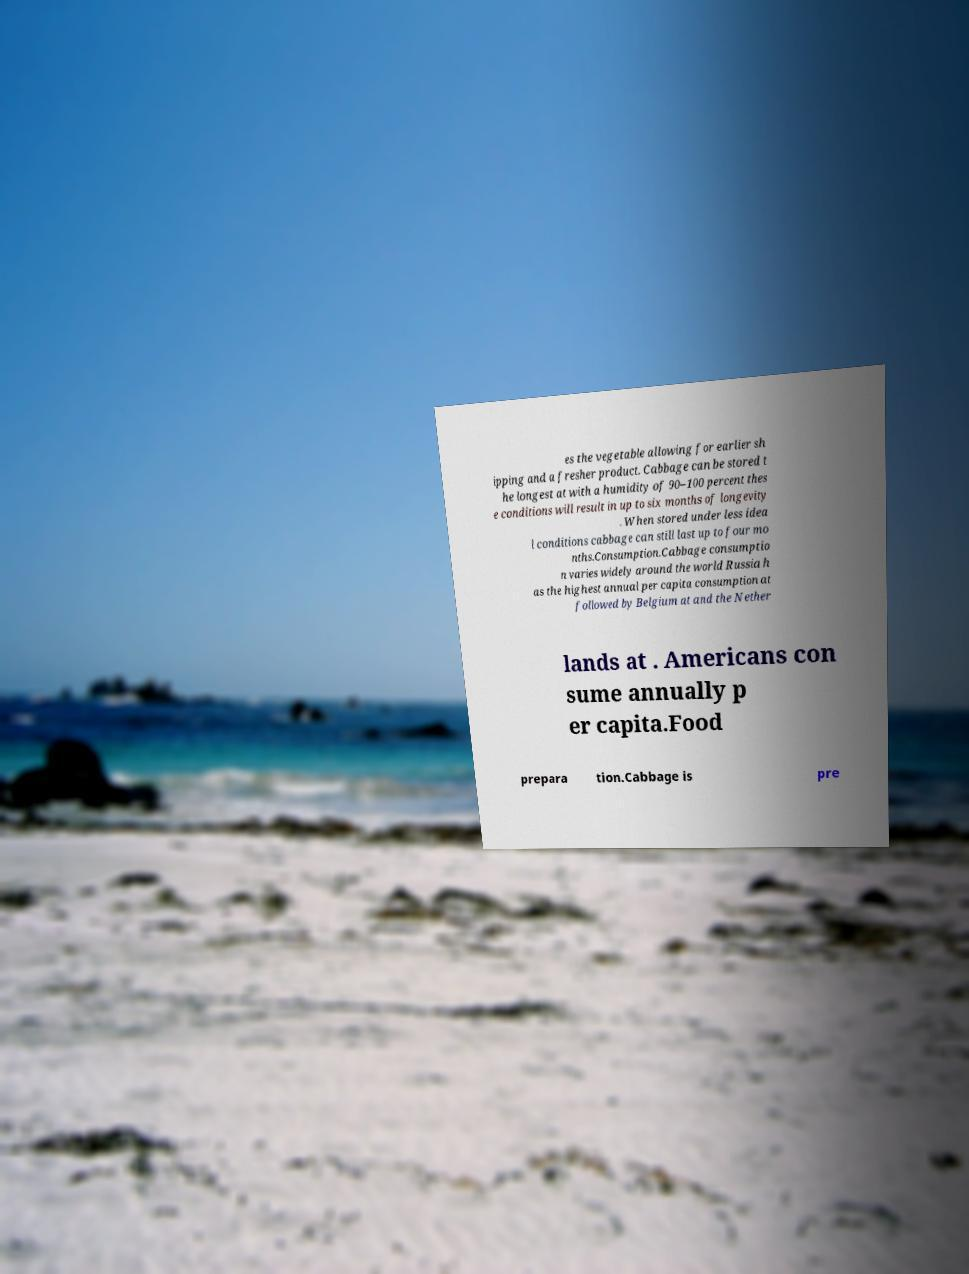Please read and relay the text visible in this image. What does it say? es the vegetable allowing for earlier sh ipping and a fresher product. Cabbage can be stored t he longest at with a humidity of 90–100 percent thes e conditions will result in up to six months of longevity . When stored under less idea l conditions cabbage can still last up to four mo nths.Consumption.Cabbage consumptio n varies widely around the world Russia h as the highest annual per capita consumption at followed by Belgium at and the Nether lands at . Americans con sume annually p er capita.Food prepara tion.Cabbage is pre 